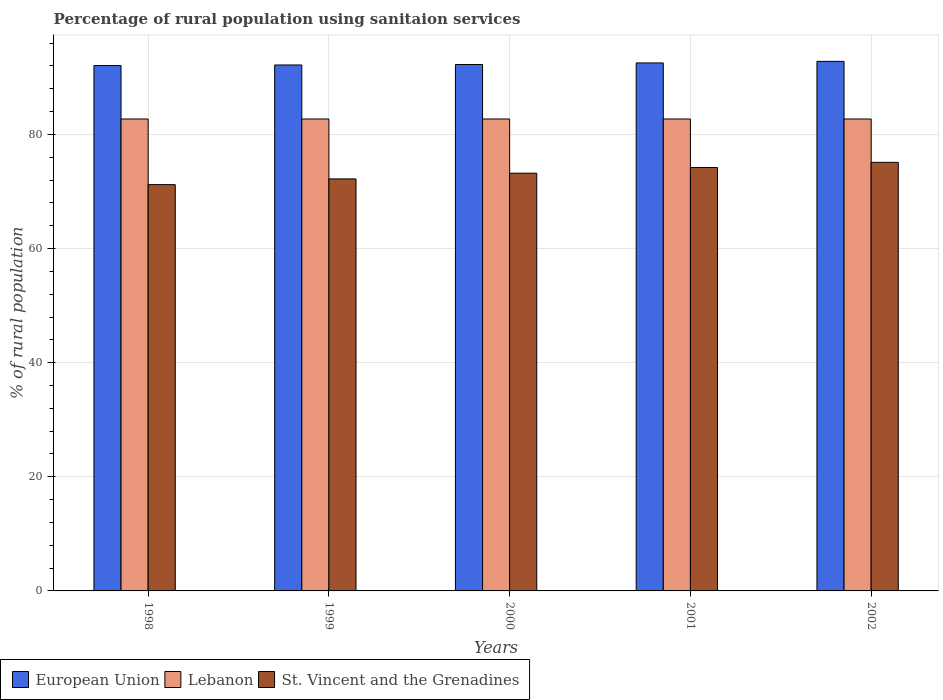Are the number of bars per tick equal to the number of legend labels?
Make the answer very short. Yes. How many bars are there on the 4th tick from the left?
Give a very brief answer. 3. What is the label of the 5th group of bars from the left?
Give a very brief answer. 2002. In how many cases, is the number of bars for a given year not equal to the number of legend labels?
Provide a succinct answer. 0. What is the percentage of rural population using sanitaion services in St. Vincent and the Grenadines in 1998?
Your answer should be very brief. 71.2. Across all years, what is the maximum percentage of rural population using sanitaion services in Lebanon?
Keep it short and to the point. 82.7. Across all years, what is the minimum percentage of rural population using sanitaion services in Lebanon?
Offer a very short reply. 82.7. In which year was the percentage of rural population using sanitaion services in Lebanon minimum?
Keep it short and to the point. 1998. What is the total percentage of rural population using sanitaion services in St. Vincent and the Grenadines in the graph?
Provide a short and direct response. 365.9. What is the difference between the percentage of rural population using sanitaion services in Lebanon in 2000 and the percentage of rural population using sanitaion services in St. Vincent and the Grenadines in 2001?
Offer a terse response. 8.5. What is the average percentage of rural population using sanitaion services in Lebanon per year?
Your answer should be compact. 82.7. In the year 1999, what is the difference between the percentage of rural population using sanitaion services in European Union and percentage of rural population using sanitaion services in St. Vincent and the Grenadines?
Keep it short and to the point. 19.96. What is the ratio of the percentage of rural population using sanitaion services in Lebanon in 1998 to that in 2002?
Provide a succinct answer. 1. Is the percentage of rural population using sanitaion services in St. Vincent and the Grenadines in 1999 less than that in 2002?
Ensure brevity in your answer.  Yes. What is the difference between the highest and the lowest percentage of rural population using sanitaion services in European Union?
Provide a short and direct response. 0.73. Is the sum of the percentage of rural population using sanitaion services in European Union in 1998 and 2001 greater than the maximum percentage of rural population using sanitaion services in Lebanon across all years?
Your response must be concise. Yes. What does the 3rd bar from the left in 1999 represents?
Offer a very short reply. St. Vincent and the Grenadines. What does the 1st bar from the right in 2001 represents?
Provide a succinct answer. St. Vincent and the Grenadines. Is it the case that in every year, the sum of the percentage of rural population using sanitaion services in Lebanon and percentage of rural population using sanitaion services in European Union is greater than the percentage of rural population using sanitaion services in St. Vincent and the Grenadines?
Offer a very short reply. Yes. How many bars are there?
Make the answer very short. 15. Are all the bars in the graph horizontal?
Provide a short and direct response. No. What is the difference between two consecutive major ticks on the Y-axis?
Your answer should be compact. 20. Where does the legend appear in the graph?
Offer a terse response. Bottom left. How are the legend labels stacked?
Keep it short and to the point. Horizontal. What is the title of the graph?
Offer a terse response. Percentage of rural population using sanitaion services. Does "Liechtenstein" appear as one of the legend labels in the graph?
Make the answer very short. No. What is the label or title of the Y-axis?
Your answer should be compact. % of rural population. What is the % of rural population of European Union in 1998?
Your answer should be compact. 92.06. What is the % of rural population in Lebanon in 1998?
Provide a succinct answer. 82.7. What is the % of rural population in St. Vincent and the Grenadines in 1998?
Keep it short and to the point. 71.2. What is the % of rural population of European Union in 1999?
Provide a succinct answer. 92.16. What is the % of rural population in Lebanon in 1999?
Your answer should be compact. 82.7. What is the % of rural population in St. Vincent and the Grenadines in 1999?
Offer a terse response. 72.2. What is the % of rural population of European Union in 2000?
Offer a very short reply. 92.25. What is the % of rural population of Lebanon in 2000?
Provide a short and direct response. 82.7. What is the % of rural population in St. Vincent and the Grenadines in 2000?
Offer a terse response. 73.2. What is the % of rural population in European Union in 2001?
Your answer should be very brief. 92.52. What is the % of rural population in Lebanon in 2001?
Your answer should be very brief. 82.7. What is the % of rural population in St. Vincent and the Grenadines in 2001?
Make the answer very short. 74.2. What is the % of rural population of European Union in 2002?
Offer a very short reply. 92.8. What is the % of rural population of Lebanon in 2002?
Offer a very short reply. 82.7. What is the % of rural population in St. Vincent and the Grenadines in 2002?
Ensure brevity in your answer.  75.1. Across all years, what is the maximum % of rural population of European Union?
Your answer should be compact. 92.8. Across all years, what is the maximum % of rural population in Lebanon?
Your answer should be very brief. 82.7. Across all years, what is the maximum % of rural population in St. Vincent and the Grenadines?
Offer a very short reply. 75.1. Across all years, what is the minimum % of rural population in European Union?
Provide a succinct answer. 92.06. Across all years, what is the minimum % of rural population of Lebanon?
Make the answer very short. 82.7. Across all years, what is the minimum % of rural population in St. Vincent and the Grenadines?
Your answer should be compact. 71.2. What is the total % of rural population of European Union in the graph?
Your answer should be very brief. 461.8. What is the total % of rural population of Lebanon in the graph?
Your answer should be compact. 413.5. What is the total % of rural population of St. Vincent and the Grenadines in the graph?
Keep it short and to the point. 365.9. What is the difference between the % of rural population in European Union in 1998 and that in 1999?
Keep it short and to the point. -0.1. What is the difference between the % of rural population in European Union in 1998 and that in 2000?
Provide a short and direct response. -0.18. What is the difference between the % of rural population in European Union in 1998 and that in 2001?
Offer a terse response. -0.46. What is the difference between the % of rural population in Lebanon in 1998 and that in 2001?
Your response must be concise. 0. What is the difference between the % of rural population of European Union in 1998 and that in 2002?
Your answer should be very brief. -0.73. What is the difference between the % of rural population of European Union in 1999 and that in 2000?
Your answer should be compact. -0.09. What is the difference between the % of rural population of Lebanon in 1999 and that in 2000?
Your answer should be compact. 0. What is the difference between the % of rural population in St. Vincent and the Grenadines in 1999 and that in 2000?
Ensure brevity in your answer.  -1. What is the difference between the % of rural population in European Union in 1999 and that in 2001?
Offer a terse response. -0.36. What is the difference between the % of rural population of Lebanon in 1999 and that in 2001?
Provide a succinct answer. 0. What is the difference between the % of rural population of St. Vincent and the Grenadines in 1999 and that in 2001?
Your answer should be compact. -2. What is the difference between the % of rural population of European Union in 1999 and that in 2002?
Keep it short and to the point. -0.64. What is the difference between the % of rural population in European Union in 2000 and that in 2001?
Give a very brief answer. -0.27. What is the difference between the % of rural population in Lebanon in 2000 and that in 2001?
Offer a terse response. 0. What is the difference between the % of rural population of St. Vincent and the Grenadines in 2000 and that in 2001?
Provide a succinct answer. -1. What is the difference between the % of rural population of European Union in 2000 and that in 2002?
Offer a terse response. -0.55. What is the difference between the % of rural population in Lebanon in 2000 and that in 2002?
Make the answer very short. 0. What is the difference between the % of rural population in St. Vincent and the Grenadines in 2000 and that in 2002?
Your answer should be very brief. -1.9. What is the difference between the % of rural population of European Union in 2001 and that in 2002?
Your answer should be very brief. -0.28. What is the difference between the % of rural population of European Union in 1998 and the % of rural population of Lebanon in 1999?
Provide a short and direct response. 9.36. What is the difference between the % of rural population of European Union in 1998 and the % of rural population of St. Vincent and the Grenadines in 1999?
Offer a terse response. 19.86. What is the difference between the % of rural population of Lebanon in 1998 and the % of rural population of St. Vincent and the Grenadines in 1999?
Offer a very short reply. 10.5. What is the difference between the % of rural population of European Union in 1998 and the % of rural population of Lebanon in 2000?
Offer a very short reply. 9.36. What is the difference between the % of rural population in European Union in 1998 and the % of rural population in St. Vincent and the Grenadines in 2000?
Your answer should be compact. 18.86. What is the difference between the % of rural population of European Union in 1998 and the % of rural population of Lebanon in 2001?
Your response must be concise. 9.36. What is the difference between the % of rural population of European Union in 1998 and the % of rural population of St. Vincent and the Grenadines in 2001?
Provide a short and direct response. 17.86. What is the difference between the % of rural population of European Union in 1998 and the % of rural population of Lebanon in 2002?
Ensure brevity in your answer.  9.36. What is the difference between the % of rural population of European Union in 1998 and the % of rural population of St. Vincent and the Grenadines in 2002?
Provide a succinct answer. 16.96. What is the difference between the % of rural population of European Union in 1999 and the % of rural population of Lebanon in 2000?
Provide a short and direct response. 9.46. What is the difference between the % of rural population of European Union in 1999 and the % of rural population of St. Vincent and the Grenadines in 2000?
Make the answer very short. 18.96. What is the difference between the % of rural population in Lebanon in 1999 and the % of rural population in St. Vincent and the Grenadines in 2000?
Provide a short and direct response. 9.5. What is the difference between the % of rural population of European Union in 1999 and the % of rural population of Lebanon in 2001?
Make the answer very short. 9.46. What is the difference between the % of rural population of European Union in 1999 and the % of rural population of St. Vincent and the Grenadines in 2001?
Offer a very short reply. 17.96. What is the difference between the % of rural population in Lebanon in 1999 and the % of rural population in St. Vincent and the Grenadines in 2001?
Ensure brevity in your answer.  8.5. What is the difference between the % of rural population in European Union in 1999 and the % of rural population in Lebanon in 2002?
Offer a very short reply. 9.46. What is the difference between the % of rural population in European Union in 1999 and the % of rural population in St. Vincent and the Grenadines in 2002?
Your answer should be very brief. 17.06. What is the difference between the % of rural population of European Union in 2000 and the % of rural population of Lebanon in 2001?
Make the answer very short. 9.55. What is the difference between the % of rural population of European Union in 2000 and the % of rural population of St. Vincent and the Grenadines in 2001?
Make the answer very short. 18.05. What is the difference between the % of rural population in Lebanon in 2000 and the % of rural population in St. Vincent and the Grenadines in 2001?
Provide a short and direct response. 8.5. What is the difference between the % of rural population in European Union in 2000 and the % of rural population in Lebanon in 2002?
Offer a very short reply. 9.55. What is the difference between the % of rural population in European Union in 2000 and the % of rural population in St. Vincent and the Grenadines in 2002?
Make the answer very short. 17.15. What is the difference between the % of rural population in Lebanon in 2000 and the % of rural population in St. Vincent and the Grenadines in 2002?
Your answer should be very brief. 7.6. What is the difference between the % of rural population in European Union in 2001 and the % of rural population in Lebanon in 2002?
Your response must be concise. 9.82. What is the difference between the % of rural population in European Union in 2001 and the % of rural population in St. Vincent and the Grenadines in 2002?
Provide a short and direct response. 17.42. What is the average % of rural population in European Union per year?
Offer a very short reply. 92.36. What is the average % of rural population in Lebanon per year?
Ensure brevity in your answer.  82.7. What is the average % of rural population in St. Vincent and the Grenadines per year?
Offer a very short reply. 73.18. In the year 1998, what is the difference between the % of rural population in European Union and % of rural population in Lebanon?
Provide a succinct answer. 9.36. In the year 1998, what is the difference between the % of rural population of European Union and % of rural population of St. Vincent and the Grenadines?
Give a very brief answer. 20.86. In the year 1998, what is the difference between the % of rural population in Lebanon and % of rural population in St. Vincent and the Grenadines?
Ensure brevity in your answer.  11.5. In the year 1999, what is the difference between the % of rural population of European Union and % of rural population of Lebanon?
Your answer should be compact. 9.46. In the year 1999, what is the difference between the % of rural population of European Union and % of rural population of St. Vincent and the Grenadines?
Provide a succinct answer. 19.96. In the year 1999, what is the difference between the % of rural population in Lebanon and % of rural population in St. Vincent and the Grenadines?
Provide a short and direct response. 10.5. In the year 2000, what is the difference between the % of rural population of European Union and % of rural population of Lebanon?
Offer a very short reply. 9.55. In the year 2000, what is the difference between the % of rural population of European Union and % of rural population of St. Vincent and the Grenadines?
Offer a very short reply. 19.05. In the year 2000, what is the difference between the % of rural population of Lebanon and % of rural population of St. Vincent and the Grenadines?
Offer a very short reply. 9.5. In the year 2001, what is the difference between the % of rural population of European Union and % of rural population of Lebanon?
Offer a very short reply. 9.82. In the year 2001, what is the difference between the % of rural population of European Union and % of rural population of St. Vincent and the Grenadines?
Make the answer very short. 18.32. In the year 2002, what is the difference between the % of rural population of European Union and % of rural population of Lebanon?
Offer a terse response. 10.1. In the year 2002, what is the difference between the % of rural population of European Union and % of rural population of St. Vincent and the Grenadines?
Your response must be concise. 17.7. What is the ratio of the % of rural population in St. Vincent and the Grenadines in 1998 to that in 1999?
Your answer should be compact. 0.99. What is the ratio of the % of rural population of St. Vincent and the Grenadines in 1998 to that in 2000?
Provide a short and direct response. 0.97. What is the ratio of the % of rural population of Lebanon in 1998 to that in 2001?
Offer a very short reply. 1. What is the ratio of the % of rural population in St. Vincent and the Grenadines in 1998 to that in 2001?
Give a very brief answer. 0.96. What is the ratio of the % of rural population of Lebanon in 1998 to that in 2002?
Offer a terse response. 1. What is the ratio of the % of rural population in St. Vincent and the Grenadines in 1998 to that in 2002?
Ensure brevity in your answer.  0.95. What is the ratio of the % of rural population in St. Vincent and the Grenadines in 1999 to that in 2000?
Provide a short and direct response. 0.99. What is the ratio of the % of rural population of St. Vincent and the Grenadines in 1999 to that in 2001?
Your response must be concise. 0.97. What is the ratio of the % of rural population of European Union in 1999 to that in 2002?
Make the answer very short. 0.99. What is the ratio of the % of rural population in St. Vincent and the Grenadines in 1999 to that in 2002?
Your response must be concise. 0.96. What is the ratio of the % of rural population of Lebanon in 2000 to that in 2001?
Provide a succinct answer. 1. What is the ratio of the % of rural population in St. Vincent and the Grenadines in 2000 to that in 2001?
Your response must be concise. 0.99. What is the ratio of the % of rural population in European Union in 2000 to that in 2002?
Provide a succinct answer. 0.99. What is the ratio of the % of rural population in St. Vincent and the Grenadines in 2000 to that in 2002?
Ensure brevity in your answer.  0.97. What is the ratio of the % of rural population in European Union in 2001 to that in 2002?
Offer a terse response. 1. What is the ratio of the % of rural population in Lebanon in 2001 to that in 2002?
Your answer should be very brief. 1. What is the difference between the highest and the second highest % of rural population of European Union?
Provide a short and direct response. 0.28. What is the difference between the highest and the second highest % of rural population in St. Vincent and the Grenadines?
Your answer should be very brief. 0.9. What is the difference between the highest and the lowest % of rural population of European Union?
Offer a terse response. 0.73. What is the difference between the highest and the lowest % of rural population of St. Vincent and the Grenadines?
Your answer should be compact. 3.9. 